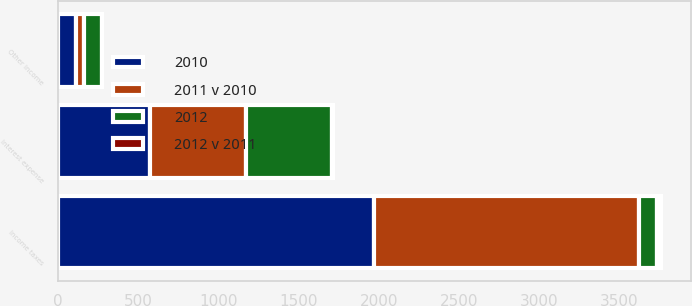<chart> <loc_0><loc_0><loc_500><loc_500><stacked_bar_chart><ecel><fcel>Other income<fcel>Interest expense<fcel>Income taxes<nl><fcel>2012<fcel>108<fcel>535<fcel>112<nl><fcel>2010<fcel>112<fcel>572<fcel>1972<nl><fcel>2011 v 2010<fcel>54<fcel>602<fcel>1653<nl><fcel>2012 v 2011<fcel>4<fcel>6<fcel>20<nl></chart> 